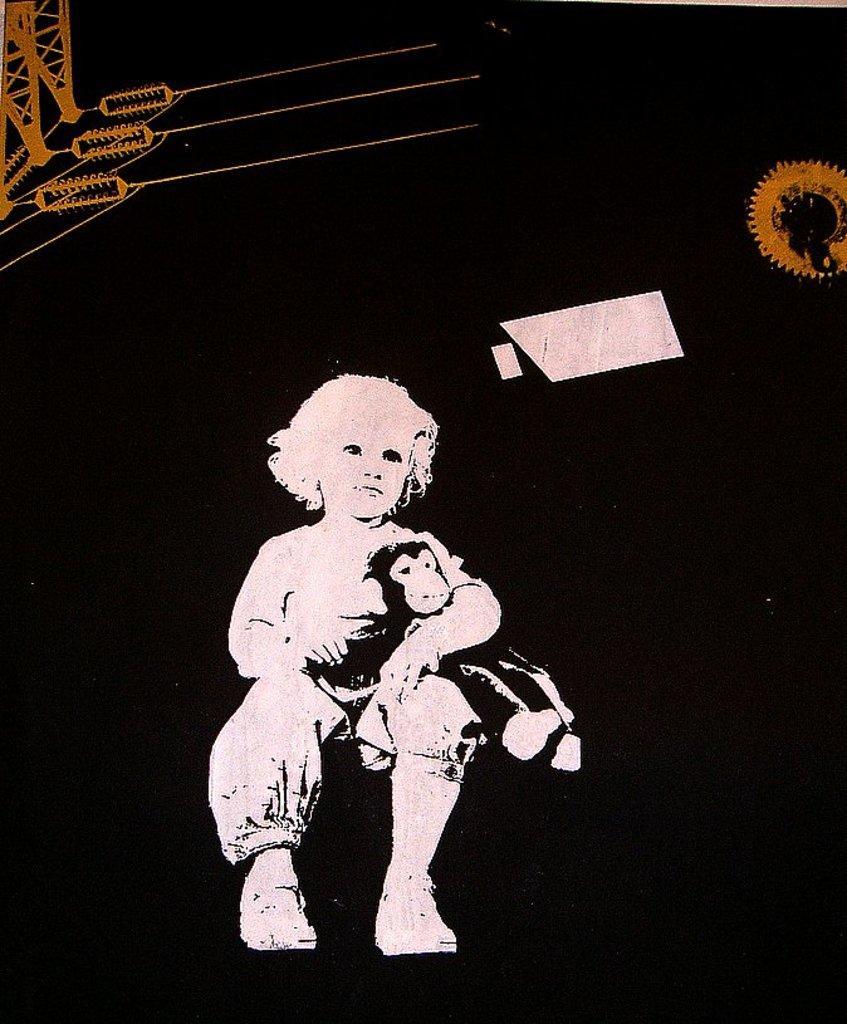Please provide a concise description of this image. Here we can see illustration picture of a kid and the kid is holding a toy, also we can see dark background. 